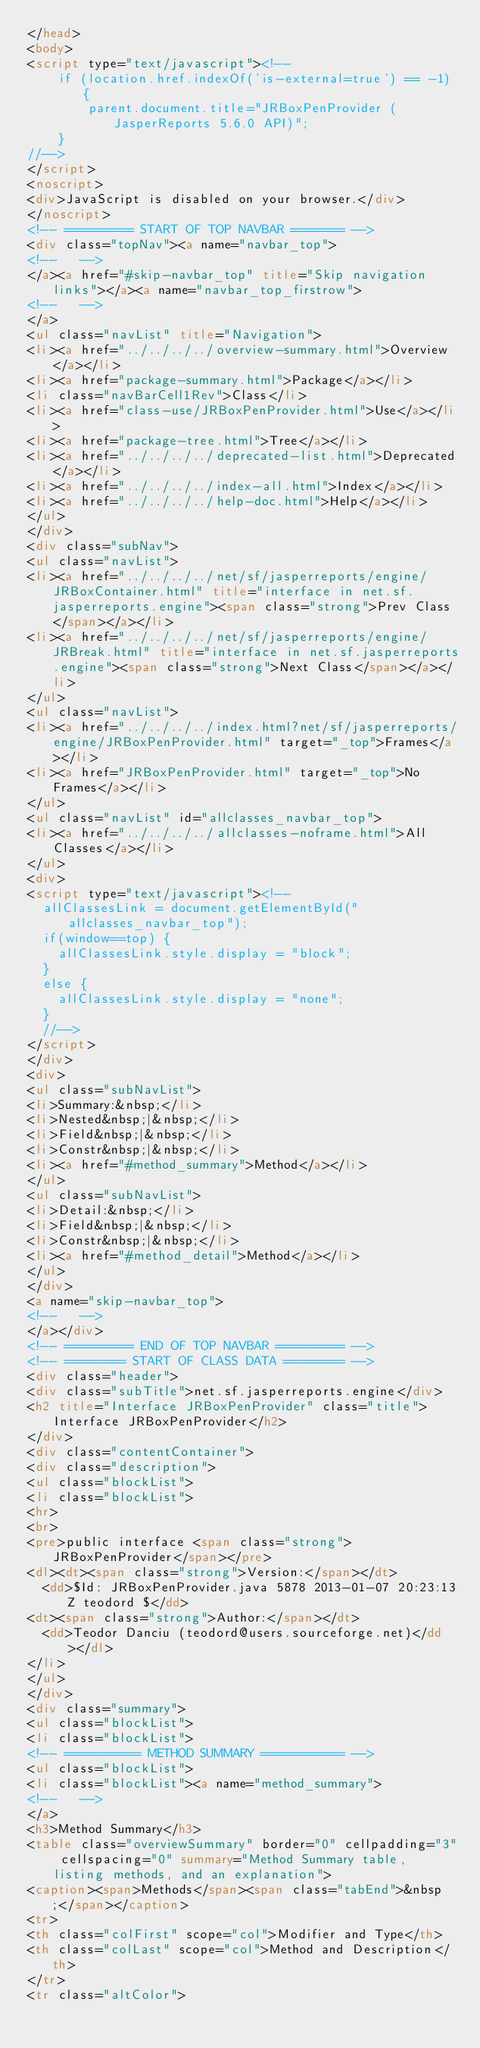Convert code to text. <code><loc_0><loc_0><loc_500><loc_500><_HTML_></head>
<body>
<script type="text/javascript"><!--
    if (location.href.indexOf('is-external=true') == -1) {
        parent.document.title="JRBoxPenProvider (JasperReports 5.6.0 API)";
    }
//-->
</script>
<noscript>
<div>JavaScript is disabled on your browser.</div>
</noscript>
<!-- ========= START OF TOP NAVBAR ======= -->
<div class="topNav"><a name="navbar_top">
<!--   -->
</a><a href="#skip-navbar_top" title="Skip navigation links"></a><a name="navbar_top_firstrow">
<!--   -->
</a>
<ul class="navList" title="Navigation">
<li><a href="../../../../overview-summary.html">Overview</a></li>
<li><a href="package-summary.html">Package</a></li>
<li class="navBarCell1Rev">Class</li>
<li><a href="class-use/JRBoxPenProvider.html">Use</a></li>
<li><a href="package-tree.html">Tree</a></li>
<li><a href="../../../../deprecated-list.html">Deprecated</a></li>
<li><a href="../../../../index-all.html">Index</a></li>
<li><a href="../../../../help-doc.html">Help</a></li>
</ul>
</div>
<div class="subNav">
<ul class="navList">
<li><a href="../../../../net/sf/jasperreports/engine/JRBoxContainer.html" title="interface in net.sf.jasperreports.engine"><span class="strong">Prev Class</span></a></li>
<li><a href="../../../../net/sf/jasperreports/engine/JRBreak.html" title="interface in net.sf.jasperreports.engine"><span class="strong">Next Class</span></a></li>
</ul>
<ul class="navList">
<li><a href="../../../../index.html?net/sf/jasperreports/engine/JRBoxPenProvider.html" target="_top">Frames</a></li>
<li><a href="JRBoxPenProvider.html" target="_top">No Frames</a></li>
</ul>
<ul class="navList" id="allclasses_navbar_top">
<li><a href="../../../../allclasses-noframe.html">All Classes</a></li>
</ul>
<div>
<script type="text/javascript"><!--
  allClassesLink = document.getElementById("allclasses_navbar_top");
  if(window==top) {
    allClassesLink.style.display = "block";
  }
  else {
    allClassesLink.style.display = "none";
  }
  //-->
</script>
</div>
<div>
<ul class="subNavList">
<li>Summary:&nbsp;</li>
<li>Nested&nbsp;|&nbsp;</li>
<li>Field&nbsp;|&nbsp;</li>
<li>Constr&nbsp;|&nbsp;</li>
<li><a href="#method_summary">Method</a></li>
</ul>
<ul class="subNavList">
<li>Detail:&nbsp;</li>
<li>Field&nbsp;|&nbsp;</li>
<li>Constr&nbsp;|&nbsp;</li>
<li><a href="#method_detail">Method</a></li>
</ul>
</div>
<a name="skip-navbar_top">
<!--   -->
</a></div>
<!-- ========= END OF TOP NAVBAR ========= -->
<!-- ======== START OF CLASS DATA ======== -->
<div class="header">
<div class="subTitle">net.sf.jasperreports.engine</div>
<h2 title="Interface JRBoxPenProvider" class="title">Interface JRBoxPenProvider</h2>
</div>
<div class="contentContainer">
<div class="description">
<ul class="blockList">
<li class="blockList">
<hr>
<br>
<pre>public interface <span class="strong">JRBoxPenProvider</span></pre>
<dl><dt><span class="strong">Version:</span></dt>
  <dd>$Id: JRBoxPenProvider.java 5878 2013-01-07 20:23:13Z teodord $</dd>
<dt><span class="strong">Author:</span></dt>
  <dd>Teodor Danciu (teodord@users.sourceforge.net)</dd></dl>
</li>
</ul>
</div>
<div class="summary">
<ul class="blockList">
<li class="blockList">
<!-- ========== METHOD SUMMARY =========== -->
<ul class="blockList">
<li class="blockList"><a name="method_summary">
<!--   -->
</a>
<h3>Method Summary</h3>
<table class="overviewSummary" border="0" cellpadding="3" cellspacing="0" summary="Method Summary table, listing methods, and an explanation">
<caption><span>Methods</span><span class="tabEnd">&nbsp;</span></caption>
<tr>
<th class="colFirst" scope="col">Modifier and Type</th>
<th class="colLast" scope="col">Method and Description</th>
</tr>
<tr class="altColor"></code> 